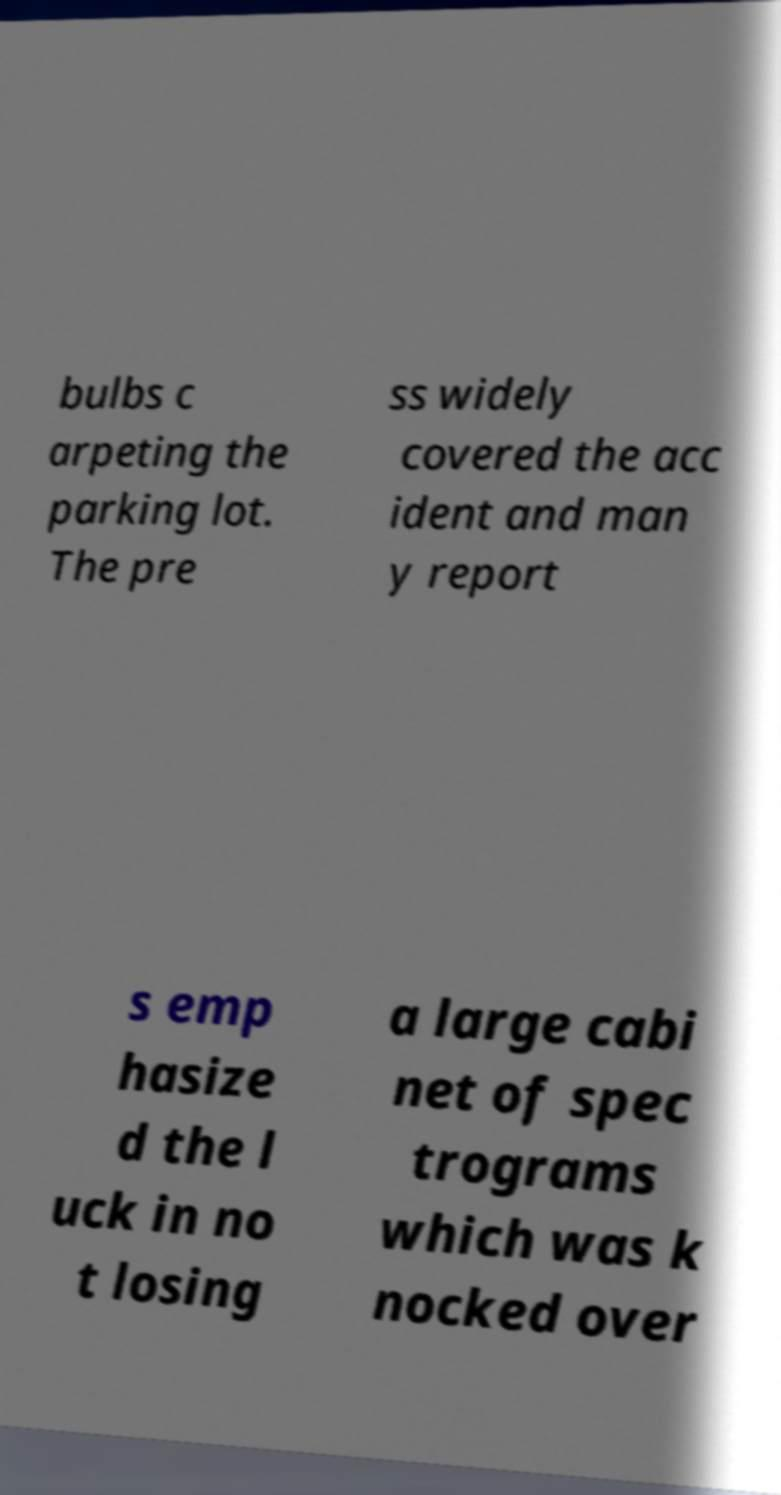What messages or text are displayed in this image? I need them in a readable, typed format. bulbs c arpeting the parking lot. The pre ss widely covered the acc ident and man y report s emp hasize d the l uck in no t losing a large cabi net of spec trograms which was k nocked over 